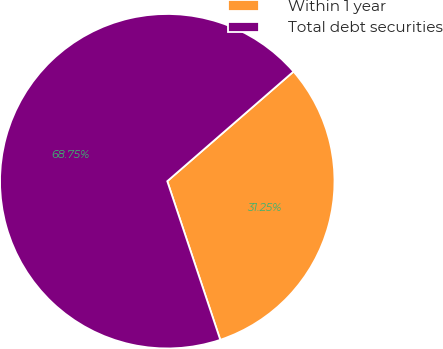Convert chart to OTSL. <chart><loc_0><loc_0><loc_500><loc_500><pie_chart><fcel>Within 1 year<fcel>Total debt securities<nl><fcel>31.25%<fcel>68.75%<nl></chart> 